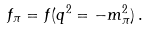<formula> <loc_0><loc_0><loc_500><loc_500>f _ { \pi } = f ( q ^ { 2 } = - m ^ { 2 } _ { \pi } ) \, .</formula> 